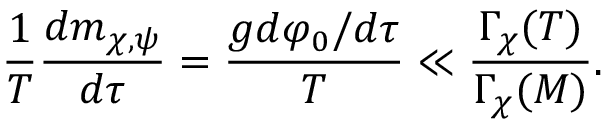<formula> <loc_0><loc_0><loc_500><loc_500>\frac { 1 } { T } \frac { d m _ { \chi , \psi } } { d \tau } = \frac { g d \varphi _ { 0 } / d \tau } { T } \ll \frac { \Gamma _ { \chi } ( T ) } { \Gamma _ { \chi } ( M ) } .</formula> 